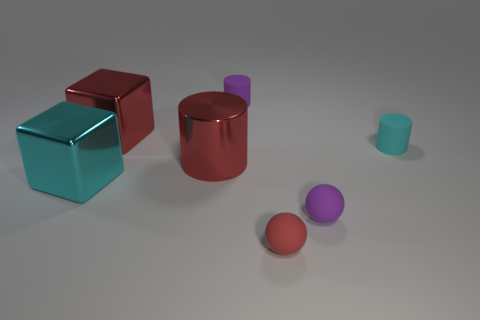Are any red blocks visible?
Provide a succinct answer. Yes. How many red rubber things have the same size as the purple rubber cylinder?
Your answer should be compact. 1. Are there more big metal cubes right of the large cyan cube than red cubes that are in front of the cyan rubber cylinder?
Make the answer very short. Yes. What material is the cube that is the same size as the cyan metal thing?
Your answer should be compact. Metal. The large cyan thing has what shape?
Your answer should be very brief. Cube. What number of yellow things are either small cylinders or big blocks?
Provide a short and direct response. 0. There is a cylinder that is the same material as the cyan cube; what is its size?
Ensure brevity in your answer.  Large. Do the small cylinder that is left of the purple sphere and the sphere that is on the right side of the small red thing have the same material?
Keep it short and to the point. Yes. What number of balls are either tiny purple rubber things or large metal objects?
Offer a very short reply. 1. There is a tiny sphere that is on the right side of the tiny red object that is on the right side of the large red cylinder; what number of objects are behind it?
Your answer should be compact. 5. 